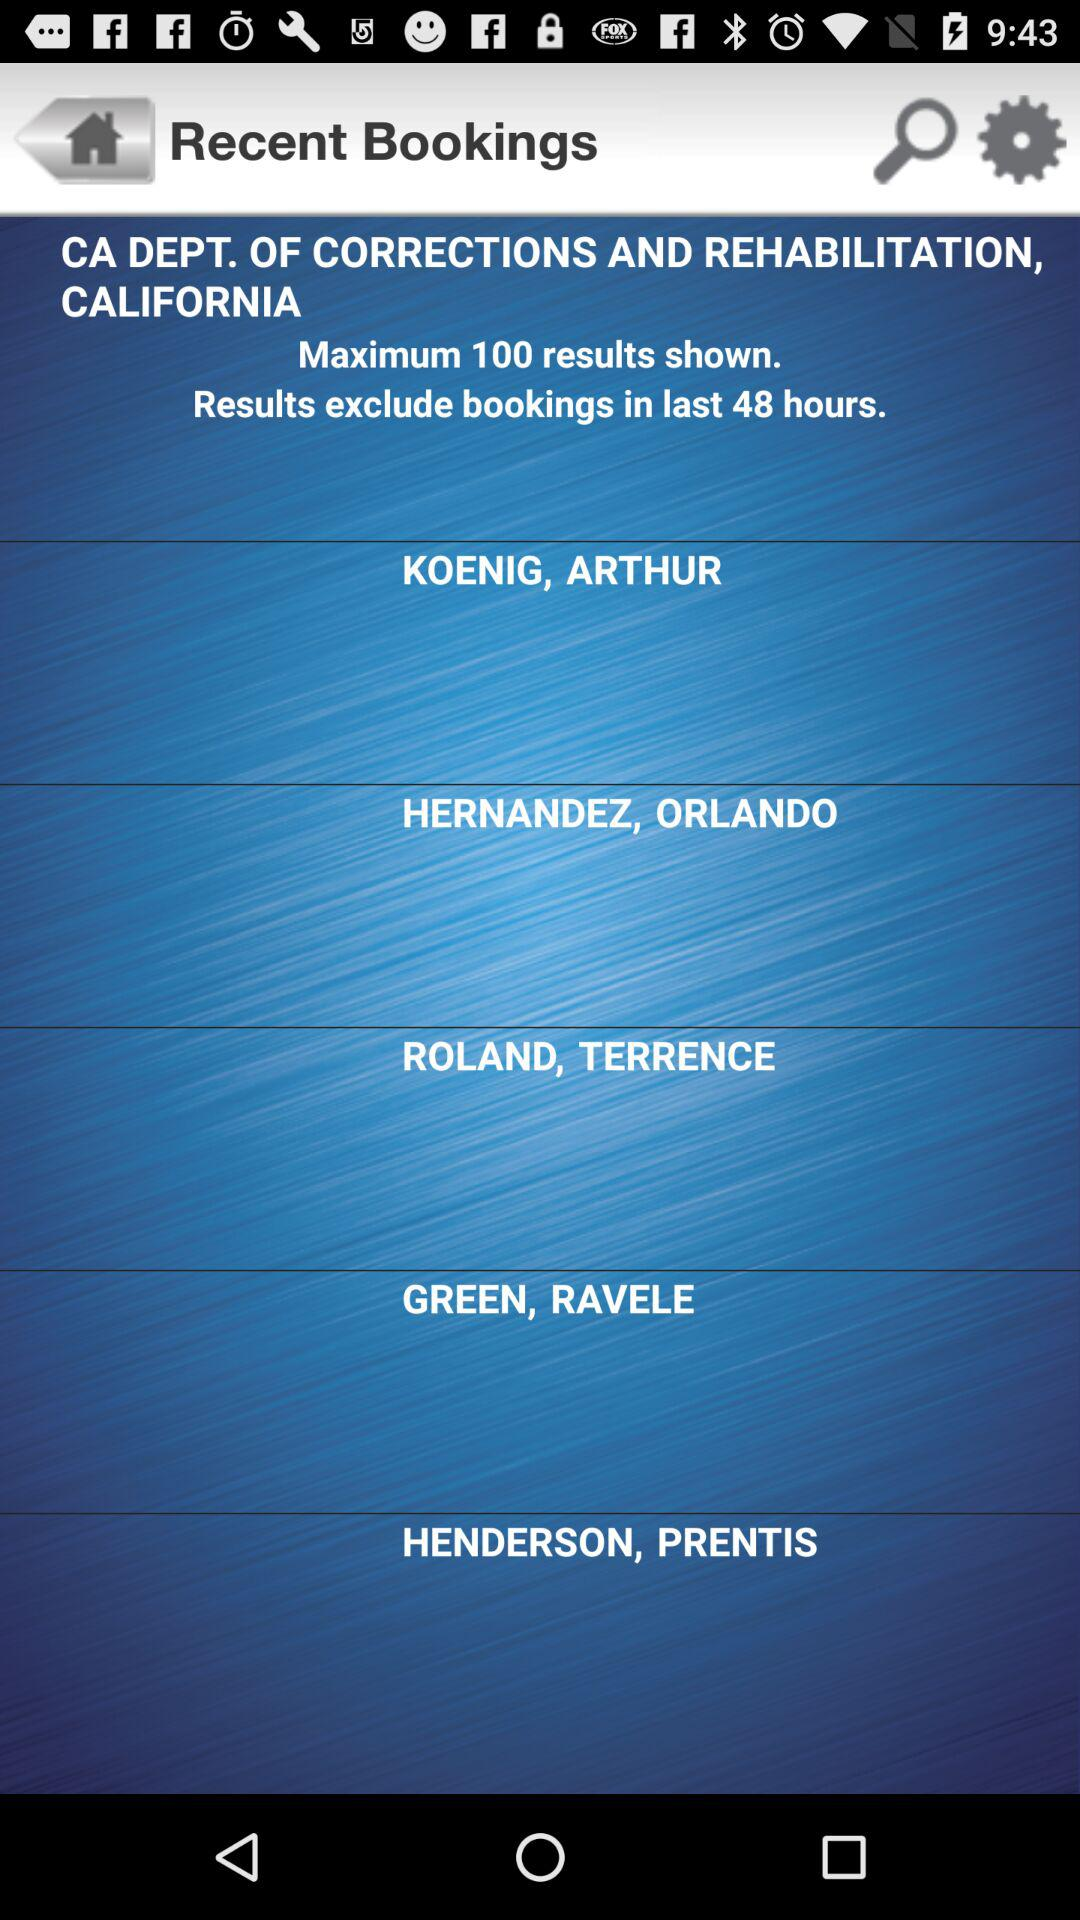Which bookings are excluded from the results? The bookings that were made in the last 48 hours are excluded from the results. 